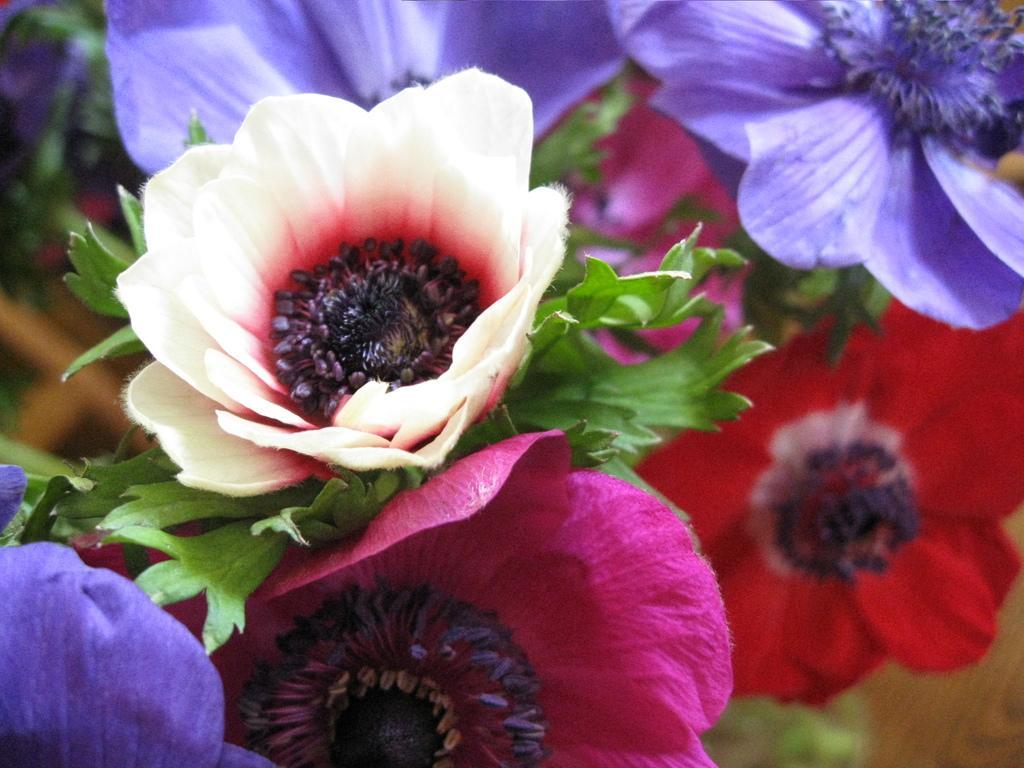Can you describe this image briefly? In this image, I can see the colorful flowers with leaves. 